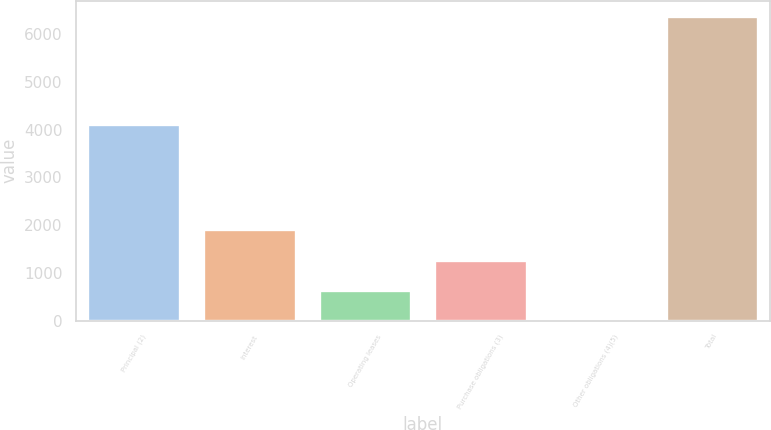Convert chart. <chart><loc_0><loc_0><loc_500><loc_500><bar_chart><fcel>Principal (2)<fcel>Interest<fcel>Operating leases<fcel>Purchase obligations (3)<fcel>Other obligations (4)(5)<fcel>Total<nl><fcel>4113<fcel>1914.7<fcel>638.9<fcel>1276.8<fcel>1<fcel>6380<nl></chart> 